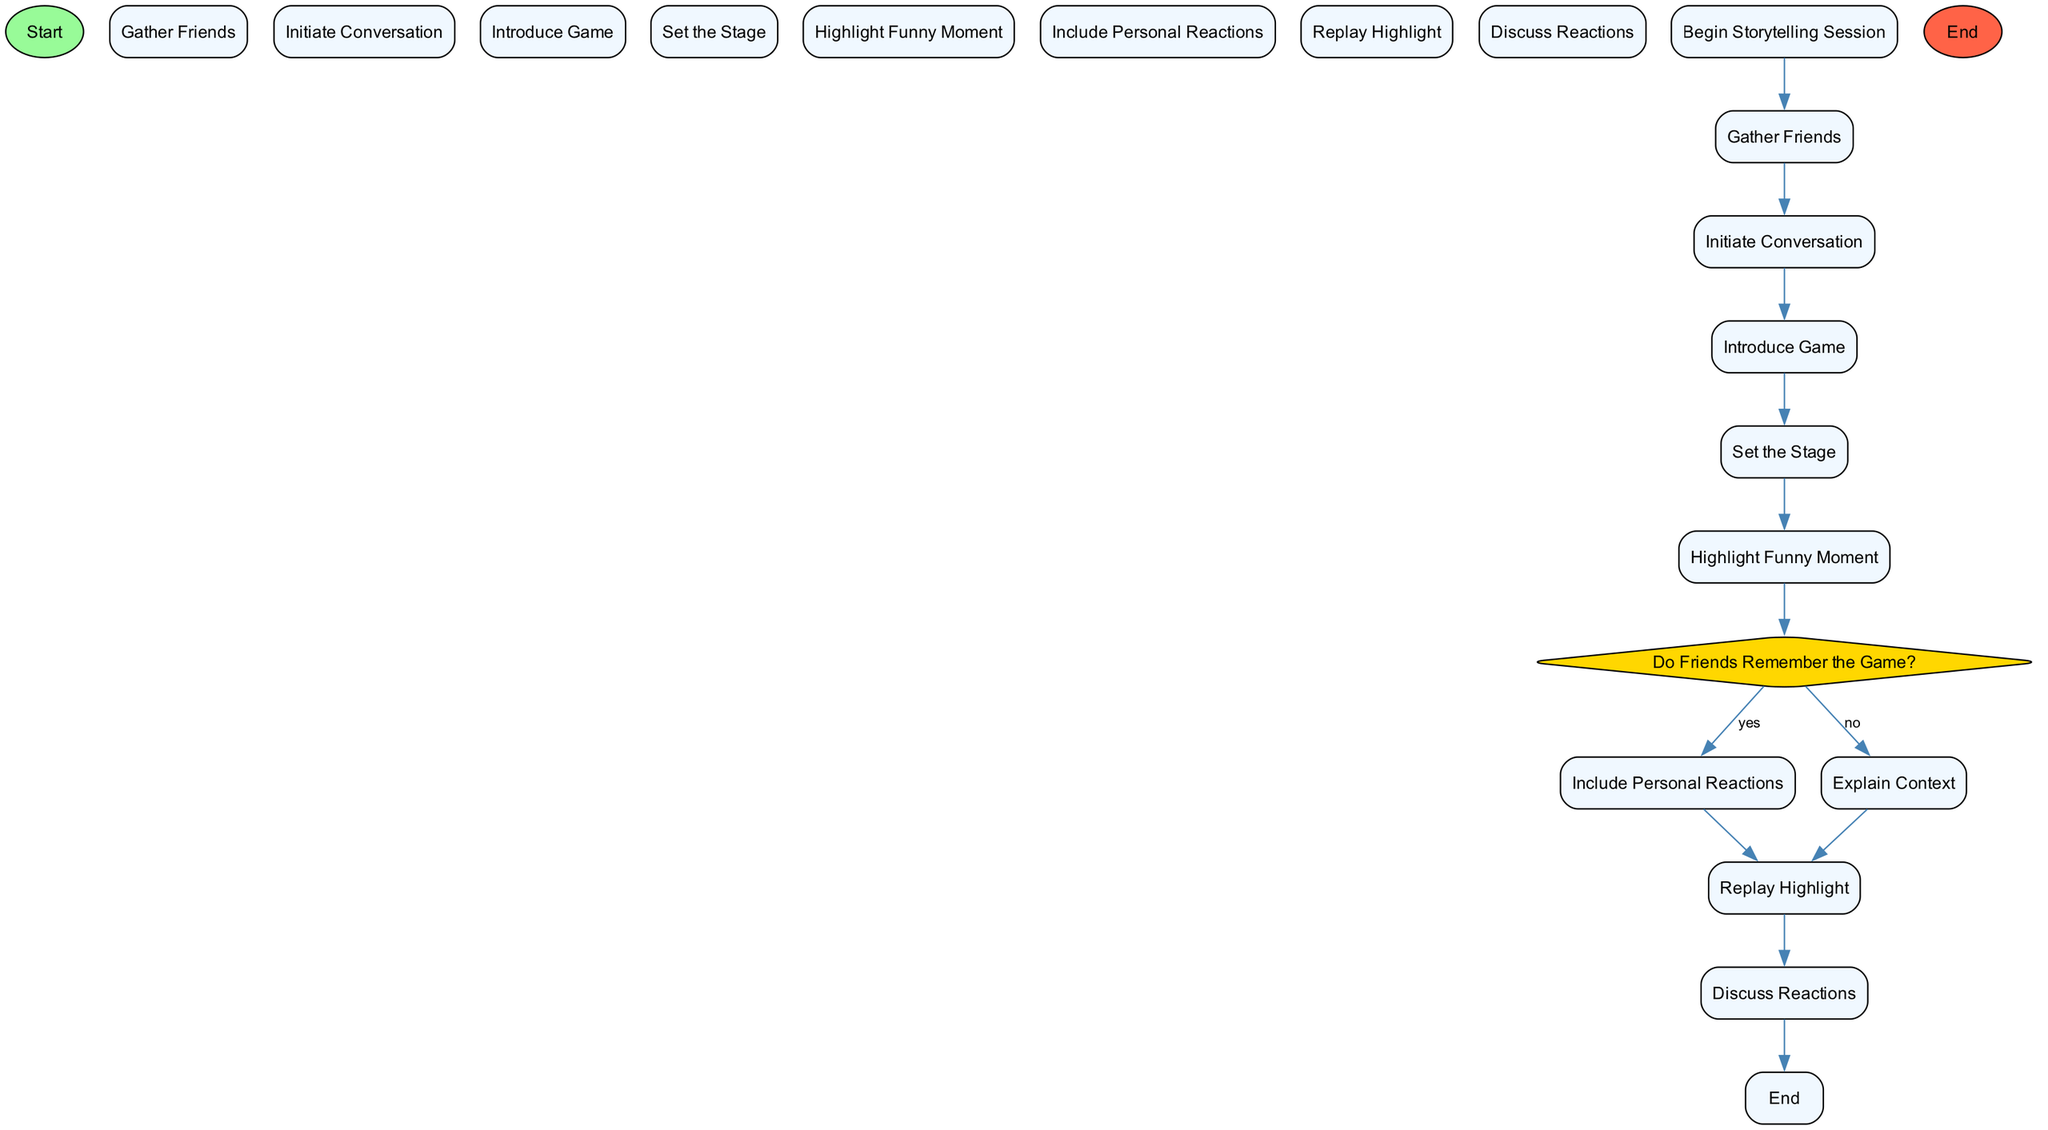What is the starting point of the activity diagram? The initial node labeled 'Start' indicates the beginning of the activity flow in the diagram.
Answer: Start How many activities are present in the diagram? Counting all listed activities in the diagram, there are eight activities outlined.
Answer: 8 What is the last step in the activity diagram? The flow concludes with the node labeled 'End', which signifies completion after discussing reactions.
Answer: End What happens if friends do not remember the game? If friends do not remember the game, the flow leads to the 'Explain Context' step to provide more background.
Answer: Explain Context Which activity directly follows 'Highlight Funny Moment'? After 'Highlight Funny Moment', the decision node 'Do Friends Remember the Game?' follows.
Answer: Do Friends Remember the Game? What type of node is used for decision-making in the diagram? The decision-making node is shaped like a diamond, which is typical for indicating branches based on conditions.
Answer: Diamond How many edges connect the nodes in the activity flow? By tracing the transitions between nodes, there are eleven edges connecting all activities and decisions in the diagram.
Answer: 11 What activity involves sharing personal reactions? 'Include Personal Reactions' is the activity where sharing personal reactions takes place after discussing the funny moment.
Answer: Include Personal Reactions Is there a video clip replay step in the diagram? Yes, the 'Replay Highlight' activity indicates that a video clip may be played during the storytelling process.
Answer: Replay Highlight 